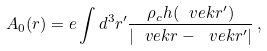<formula> <loc_0><loc_0><loc_500><loc_500>A _ { 0 } ( r ) = e \int d ^ { 3 } r ^ { \prime } \frac { \rho _ { c } h ( \ v e k { r } ^ { \prime } ) } { | \ v e k { r } - \ v e k { r } ^ { \prime } | } \, ,</formula> 